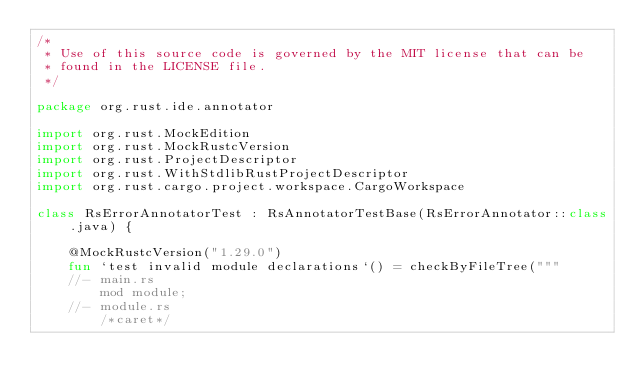<code> <loc_0><loc_0><loc_500><loc_500><_Kotlin_>/*
 * Use of this source code is governed by the MIT license that can be
 * found in the LICENSE file.
 */

package org.rust.ide.annotator

import org.rust.MockEdition
import org.rust.MockRustcVersion
import org.rust.ProjectDescriptor
import org.rust.WithStdlibRustProjectDescriptor
import org.rust.cargo.project.workspace.CargoWorkspace

class RsErrorAnnotatorTest : RsAnnotatorTestBase(RsErrorAnnotator::class.java) {

    @MockRustcVersion("1.29.0")
    fun `test invalid module declarations`() = checkByFileTree("""
    //- main.rs
        mod module;
    //- module.rs
        /*caret*/</code> 